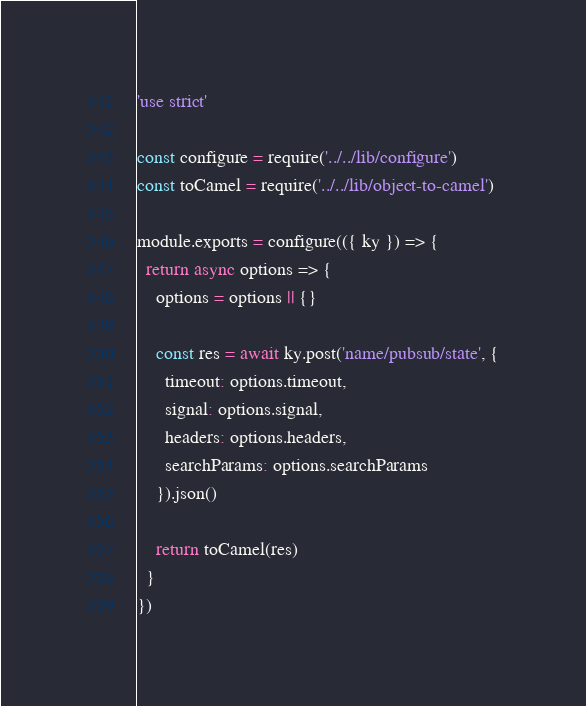<code> <loc_0><loc_0><loc_500><loc_500><_JavaScript_>'use strict'

const configure = require('../../lib/configure')
const toCamel = require('../../lib/object-to-camel')

module.exports = configure(({ ky }) => {
  return async options => {
    options = options || {}

    const res = await ky.post('name/pubsub/state', {
      timeout: options.timeout,
      signal: options.signal,
      headers: options.headers,
      searchParams: options.searchParams
    }).json()

    return toCamel(res)
  }
})
</code> 